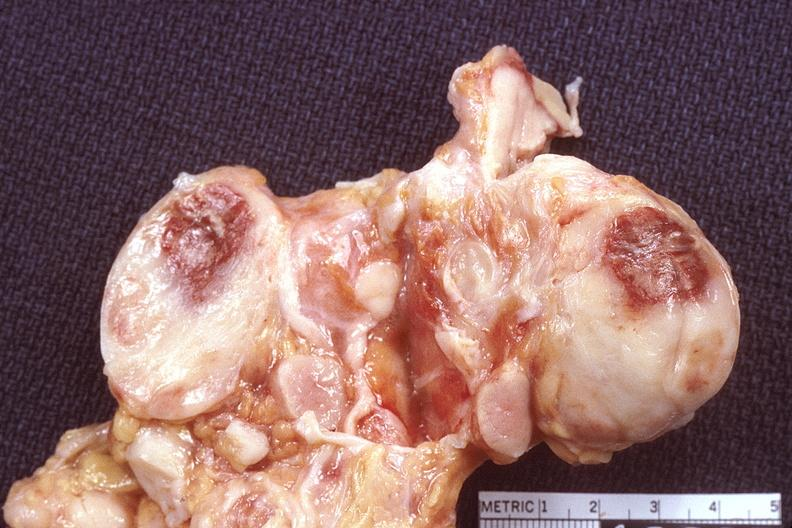does this image show lymph nodes, lymphoma?
Answer the question using a single word or phrase. Yes 